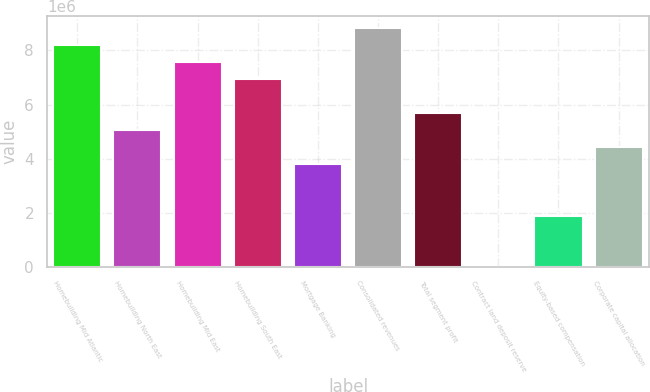Convert chart. <chart><loc_0><loc_0><loc_500><loc_500><bar_chart><fcel>Homebuilding Mid Atlantic<fcel>Homebuilding North East<fcel>Homebuilding Mid East<fcel>Homebuilding South East<fcel>Mortgage Banking<fcel>Consolidated revenues<fcel>Total segment profit<fcel>Contract land deposit reserve<fcel>Equity-based compensation<fcel>Corporate capital allocation<nl><fcel>8.1972e+06<fcel>5.04493e+06<fcel>7.56675e+06<fcel>6.93629e+06<fcel>3.78403e+06<fcel>8.82765e+06<fcel>5.67539e+06<fcel>1307<fcel>1.89267e+06<fcel>4.41448e+06<nl></chart> 